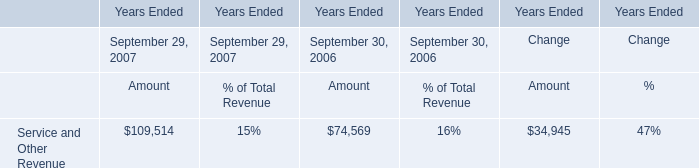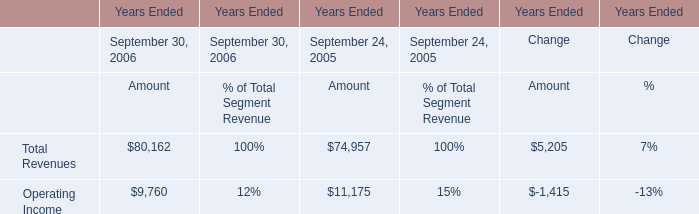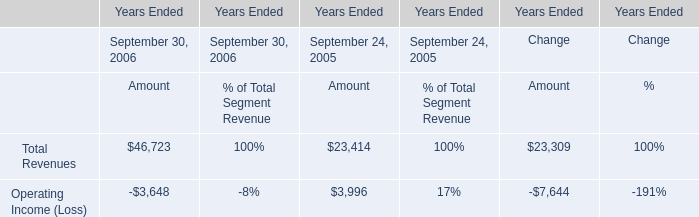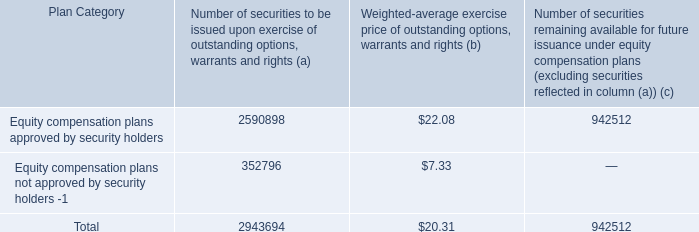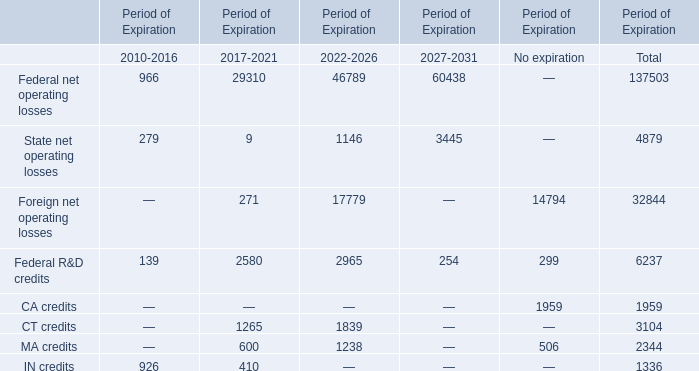What is the Foreign net operating losses for the Period of Expiration 2022-2026? 
Answer: 17779. 